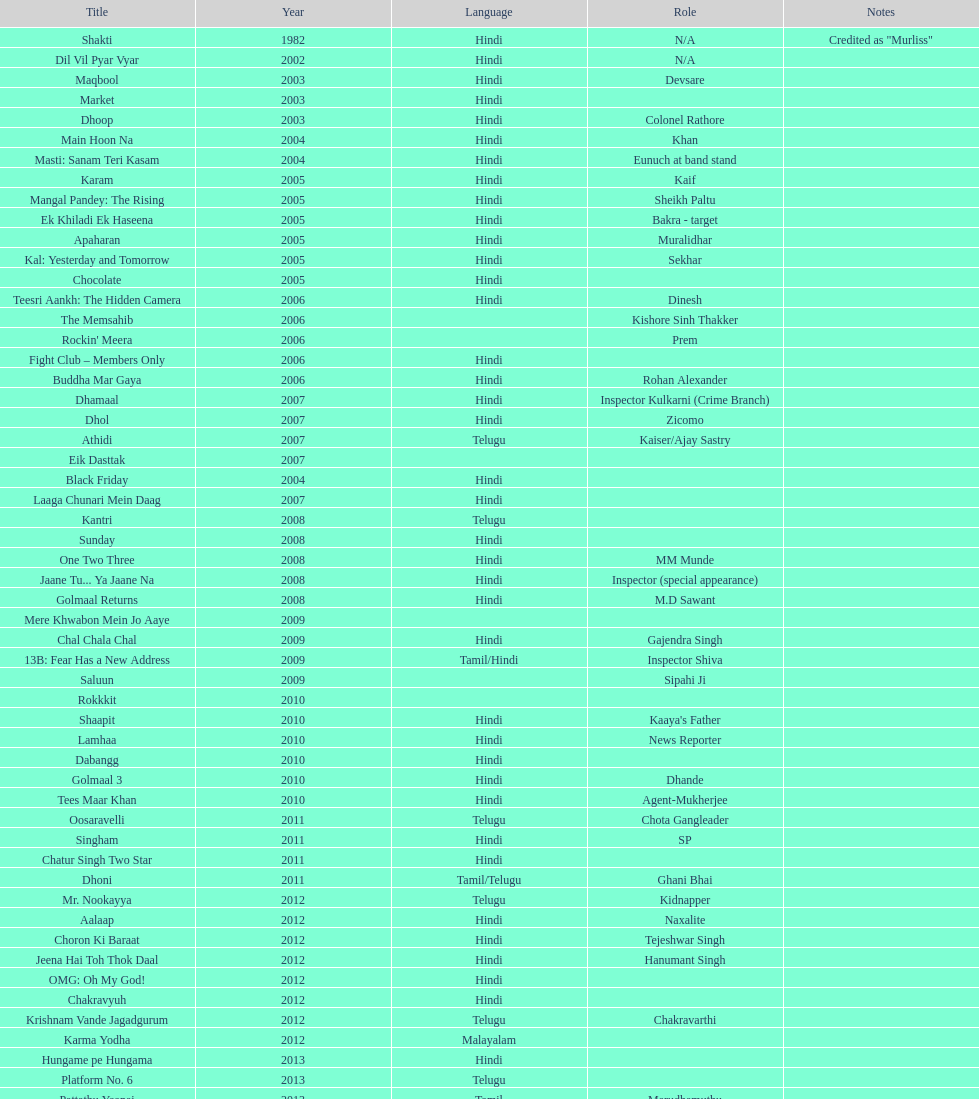What movie did this actor star in after they starred in dil vil pyar vyar in 2002? Maqbool. 